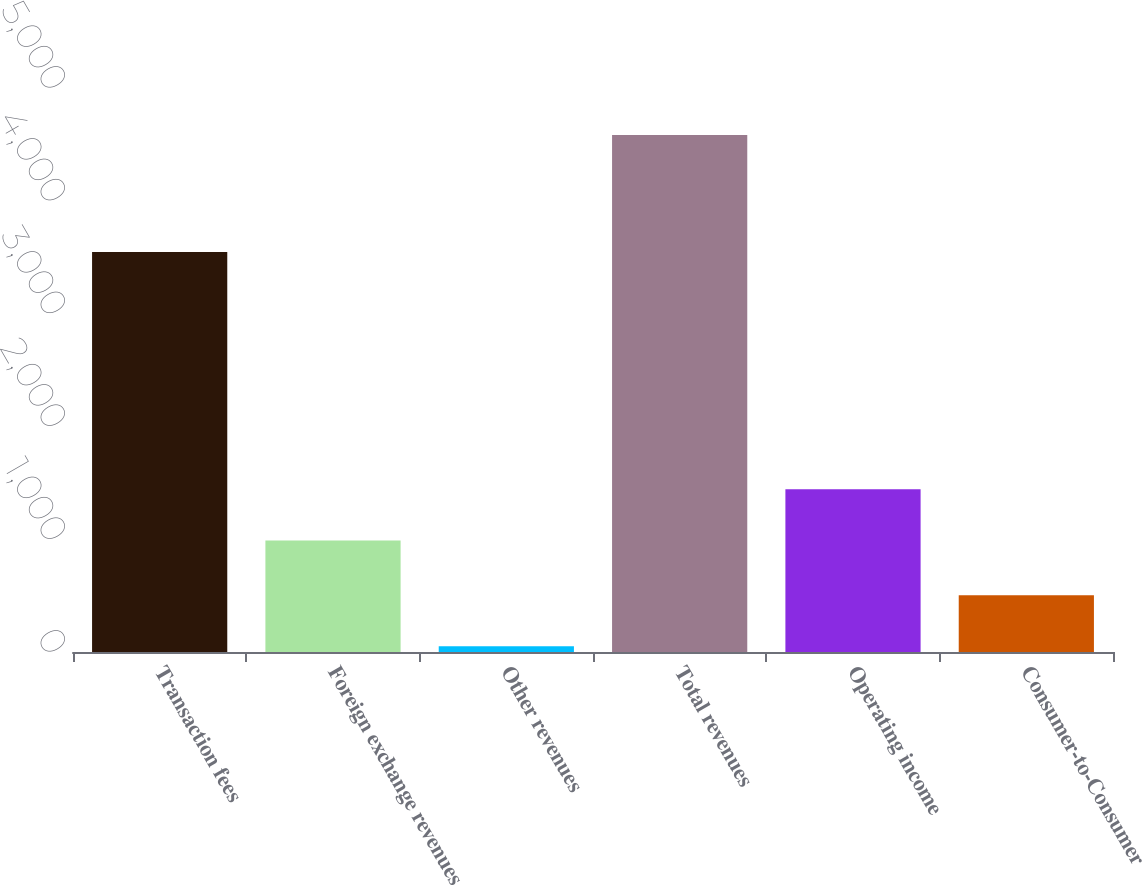Convert chart to OTSL. <chart><loc_0><loc_0><loc_500><loc_500><bar_chart><fcel>Transaction fees<fcel>Foreign exchange revenues<fcel>Other revenues<fcel>Total revenues<fcel>Operating income<fcel>Consumer-to-Consumer<nl><fcel>3545.6<fcel>988.5<fcel>50.2<fcel>4584.3<fcel>1441.91<fcel>503.61<nl></chart> 